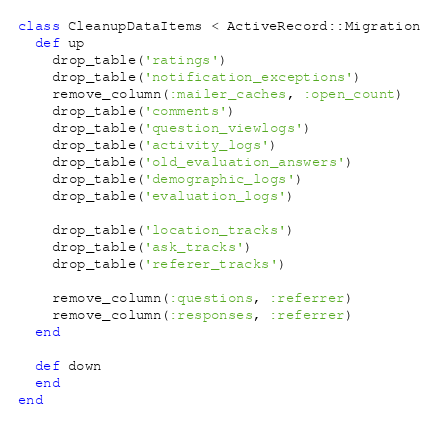Convert code to text. <code><loc_0><loc_0><loc_500><loc_500><_Ruby_>class CleanupDataItems < ActiveRecord::Migration
  def up
    drop_table('ratings')
    drop_table('notification_exceptions')
    remove_column(:mailer_caches, :open_count)
    drop_table('comments')
    drop_table('question_viewlogs')
    drop_table('activity_logs')
    drop_table('old_evaluation_answers')
    drop_table('demographic_logs')
    drop_table('evaluation_logs')

    drop_table('location_tracks')
    drop_table('ask_tracks')
    drop_table('referer_tracks')

    remove_column(:questions, :referrer)
    remove_column(:responses, :referrer)
  end

  def down
  end
end
</code> 